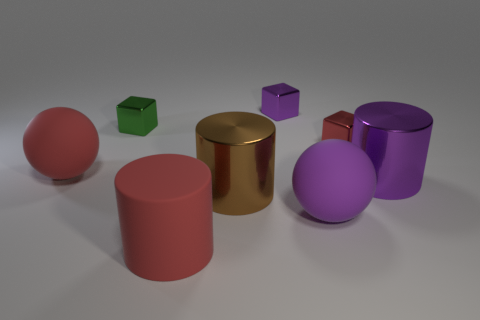Are there fewer small things that are on the left side of the purple cube than small red metallic blocks right of the red metal cube?
Offer a very short reply. No. There is a big matte thing that is left of the purple cube and on the right side of the small green object; what shape is it?
Your response must be concise. Cylinder. What number of large matte objects have the same shape as the big brown metallic object?
Ensure brevity in your answer.  1. There is a red cylinder that is the same material as the purple ball; what size is it?
Ensure brevity in your answer.  Large. How many other things have the same size as the brown shiny thing?
Give a very brief answer. 4. There is a metallic block that is the same color as the rubber cylinder; what size is it?
Give a very brief answer. Small. There is a ball behind the big metal object to the right of the purple rubber thing; what color is it?
Provide a succinct answer. Red. Are there any shiny blocks that have the same color as the rubber cylinder?
Give a very brief answer. Yes. What color is the other sphere that is the same size as the red matte ball?
Give a very brief answer. Purple. Is the material of the purple object that is to the left of the purple matte thing the same as the tiny red block?
Offer a terse response. Yes. 